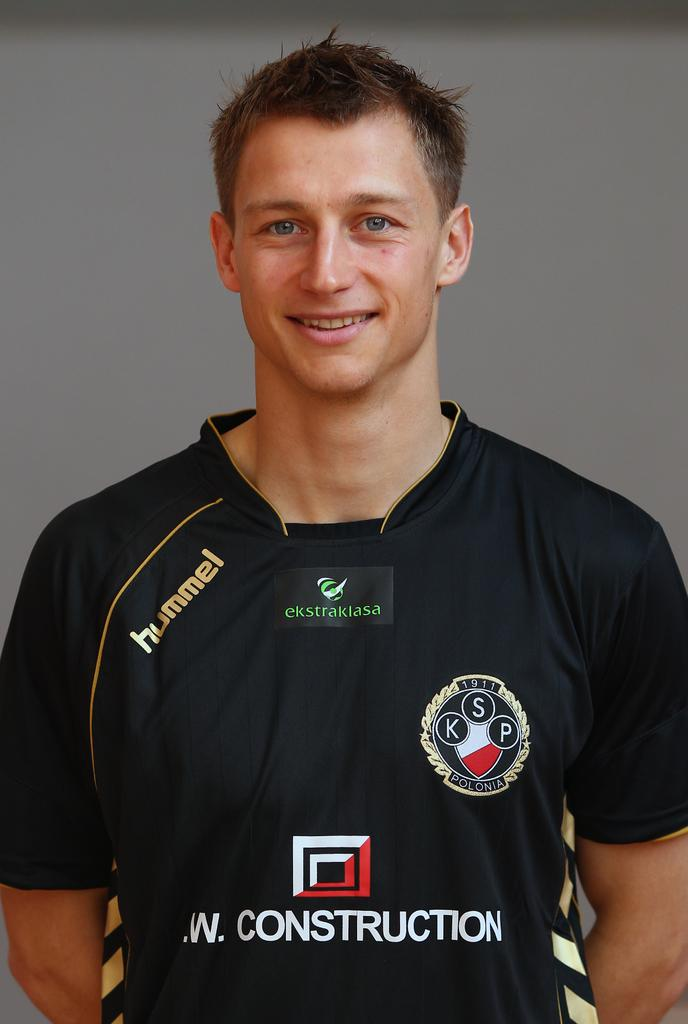<image>
Render a clear and concise summary of the photo. Man wearing a jersey that says construction on it. 